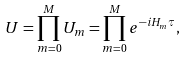<formula> <loc_0><loc_0><loc_500><loc_500>U = \prod _ { m = 0 } ^ { M } U _ { m } = \prod _ { m = 0 } ^ { M } e ^ { - i H _ { m } \tau } ,</formula> 